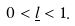Convert formula to latex. <formula><loc_0><loc_0><loc_500><loc_500>0 < \underline { l } < 1 .</formula> 